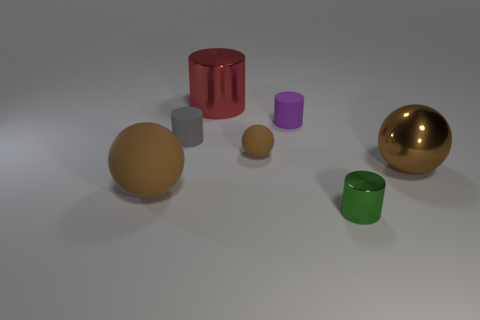How many things are either brown spheres that are on the right side of the large rubber thing or small matte cylinders to the left of the purple cylinder?
Make the answer very short. 3. Is the number of big cylinders that are to the right of the big red cylinder greater than the number of purple objects in front of the large matte thing?
Make the answer very short. No. What color is the tiny object right of the small purple object?
Offer a very short reply. Green. Is there a brown thing that has the same shape as the red shiny thing?
Provide a succinct answer. No. How many gray things are either big matte things or small balls?
Keep it short and to the point. 0. Is there a green cylinder of the same size as the purple matte cylinder?
Your response must be concise. Yes. What number of red metal spheres are there?
Ensure brevity in your answer.  0. What number of tiny objects are either spheres or brown matte balls?
Offer a terse response. 1. There is a tiny thing in front of the brown matte ball in front of the brown rubber sphere behind the brown metallic ball; what color is it?
Your answer should be compact. Green. What number of other things are the same color as the large rubber sphere?
Provide a succinct answer. 2. 